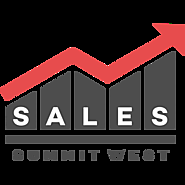How does the visual design of the graph communicate effectiveness in sales? The visual design of the graph is particularly effective in communicating sales success due to its ascending nature. The bars increase in height from left to right, visually representing growth over time. The culmination with a red arrow not only draws attention but also universally symbolizes upward movement, commonly understood to represent improvement or progress. This type of design is simple yet powerful, efficiently conveying the concept of increasing sales or achieving higher goals, which could inspire potential attendees or participants of the Sales Summit West. 